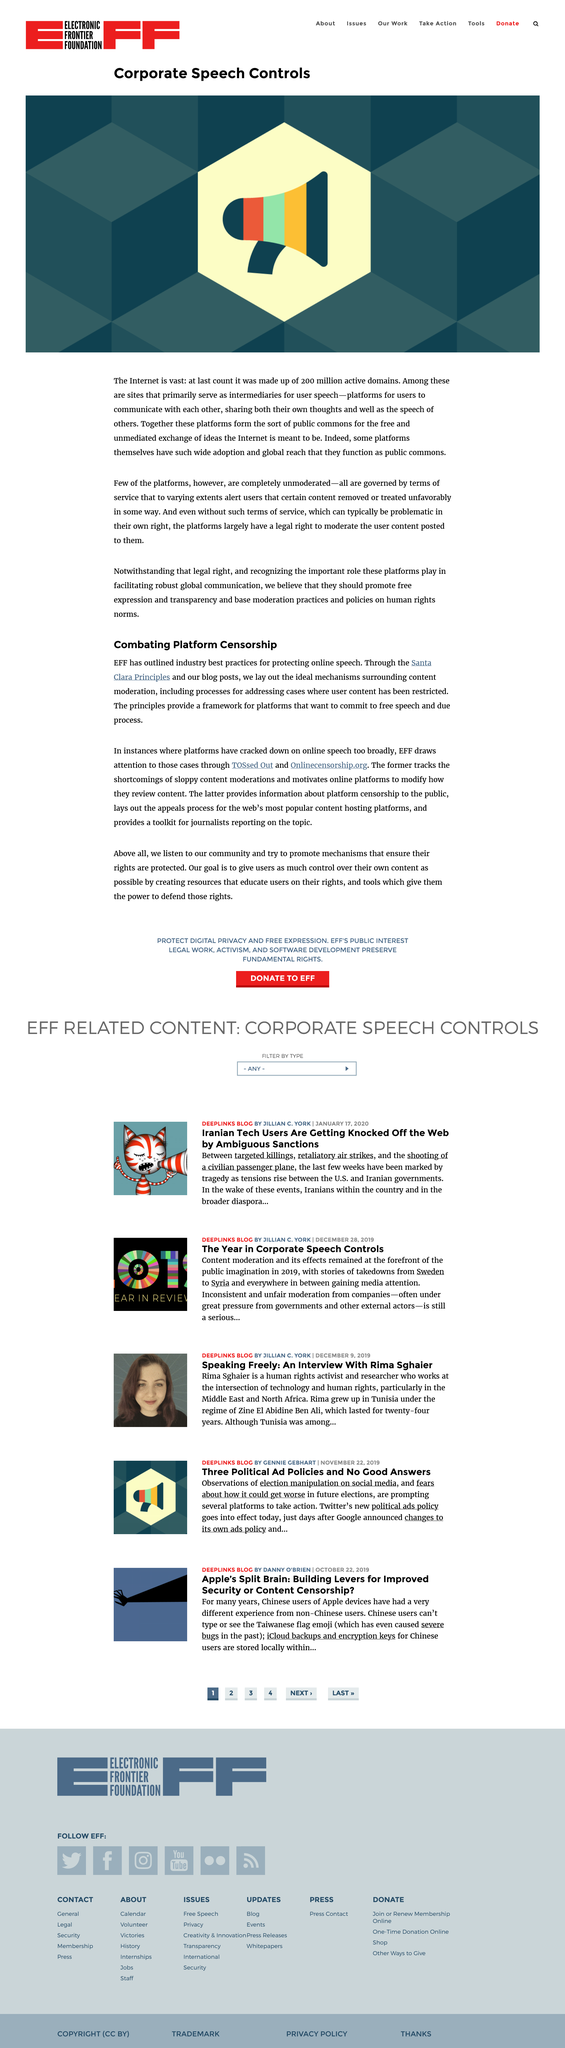Specify some key components in this picture. There are a few unmoderated platforms available that are completely unmoderated. It is legally permissible for a platform to moderate user-posted content. Yes, some platforms have achieved such wide adoption and global research that they function as public commons. 